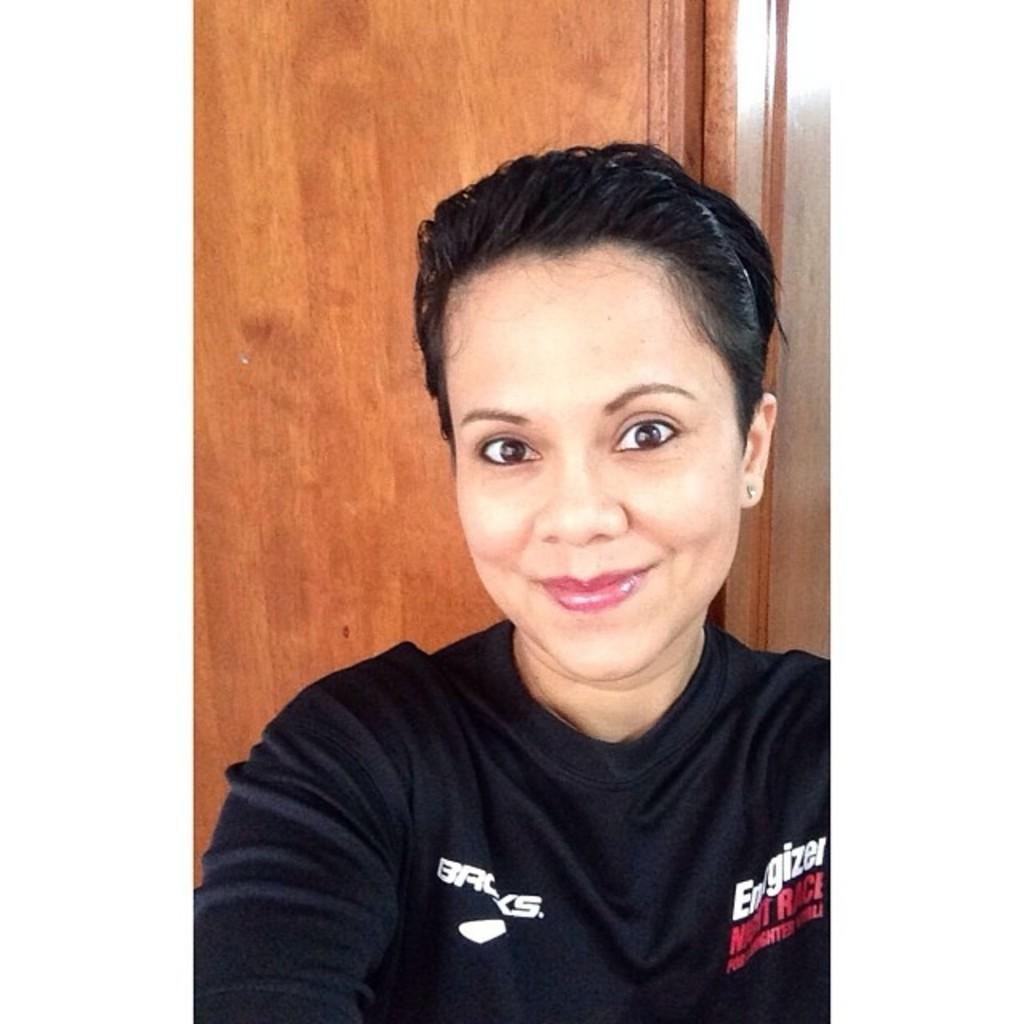<image>
Relay a brief, clear account of the picture shown. A woman taking a selfie wearing a black tee shirt  that is advertising the brand energizer on the upper right side. 